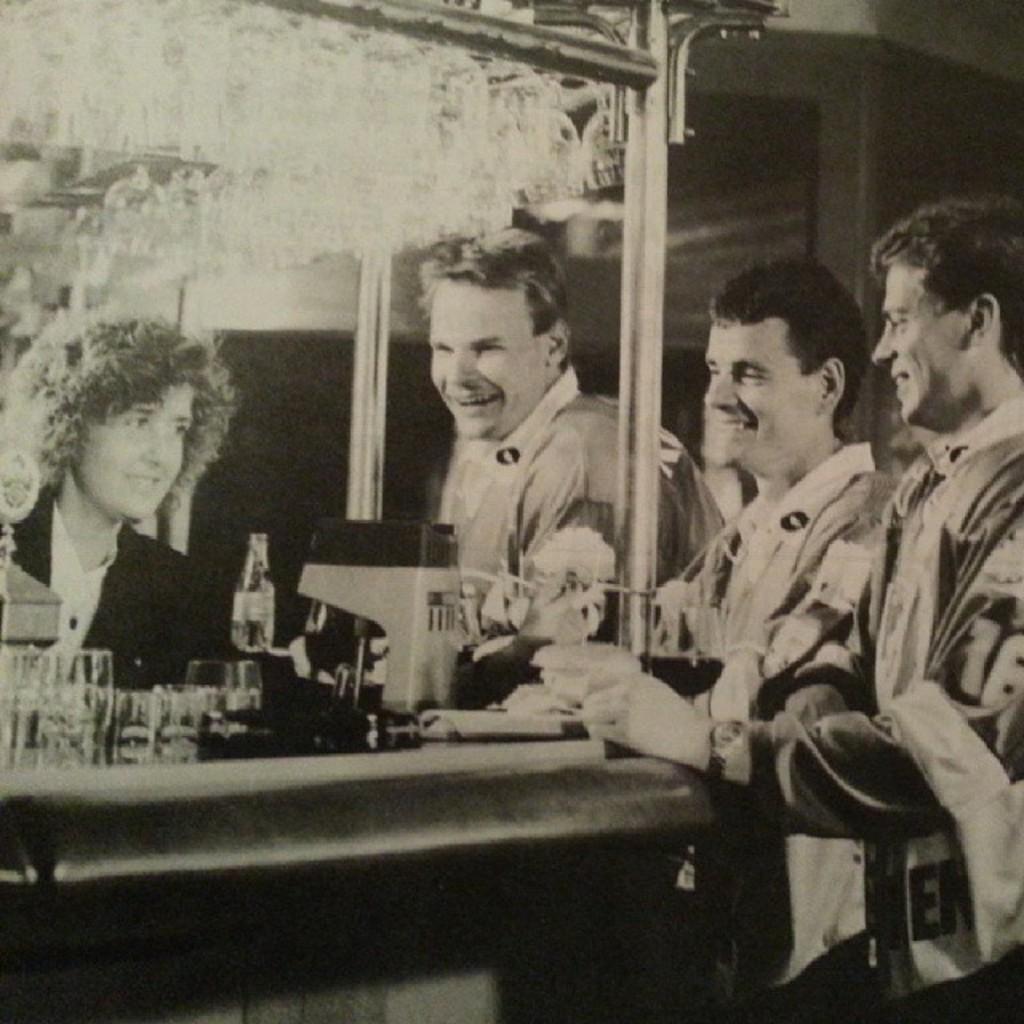How would you summarize this image in a sentence or two? A black and white picture. These persons are holding a smile. On this table there are glasses, bottle and things. 